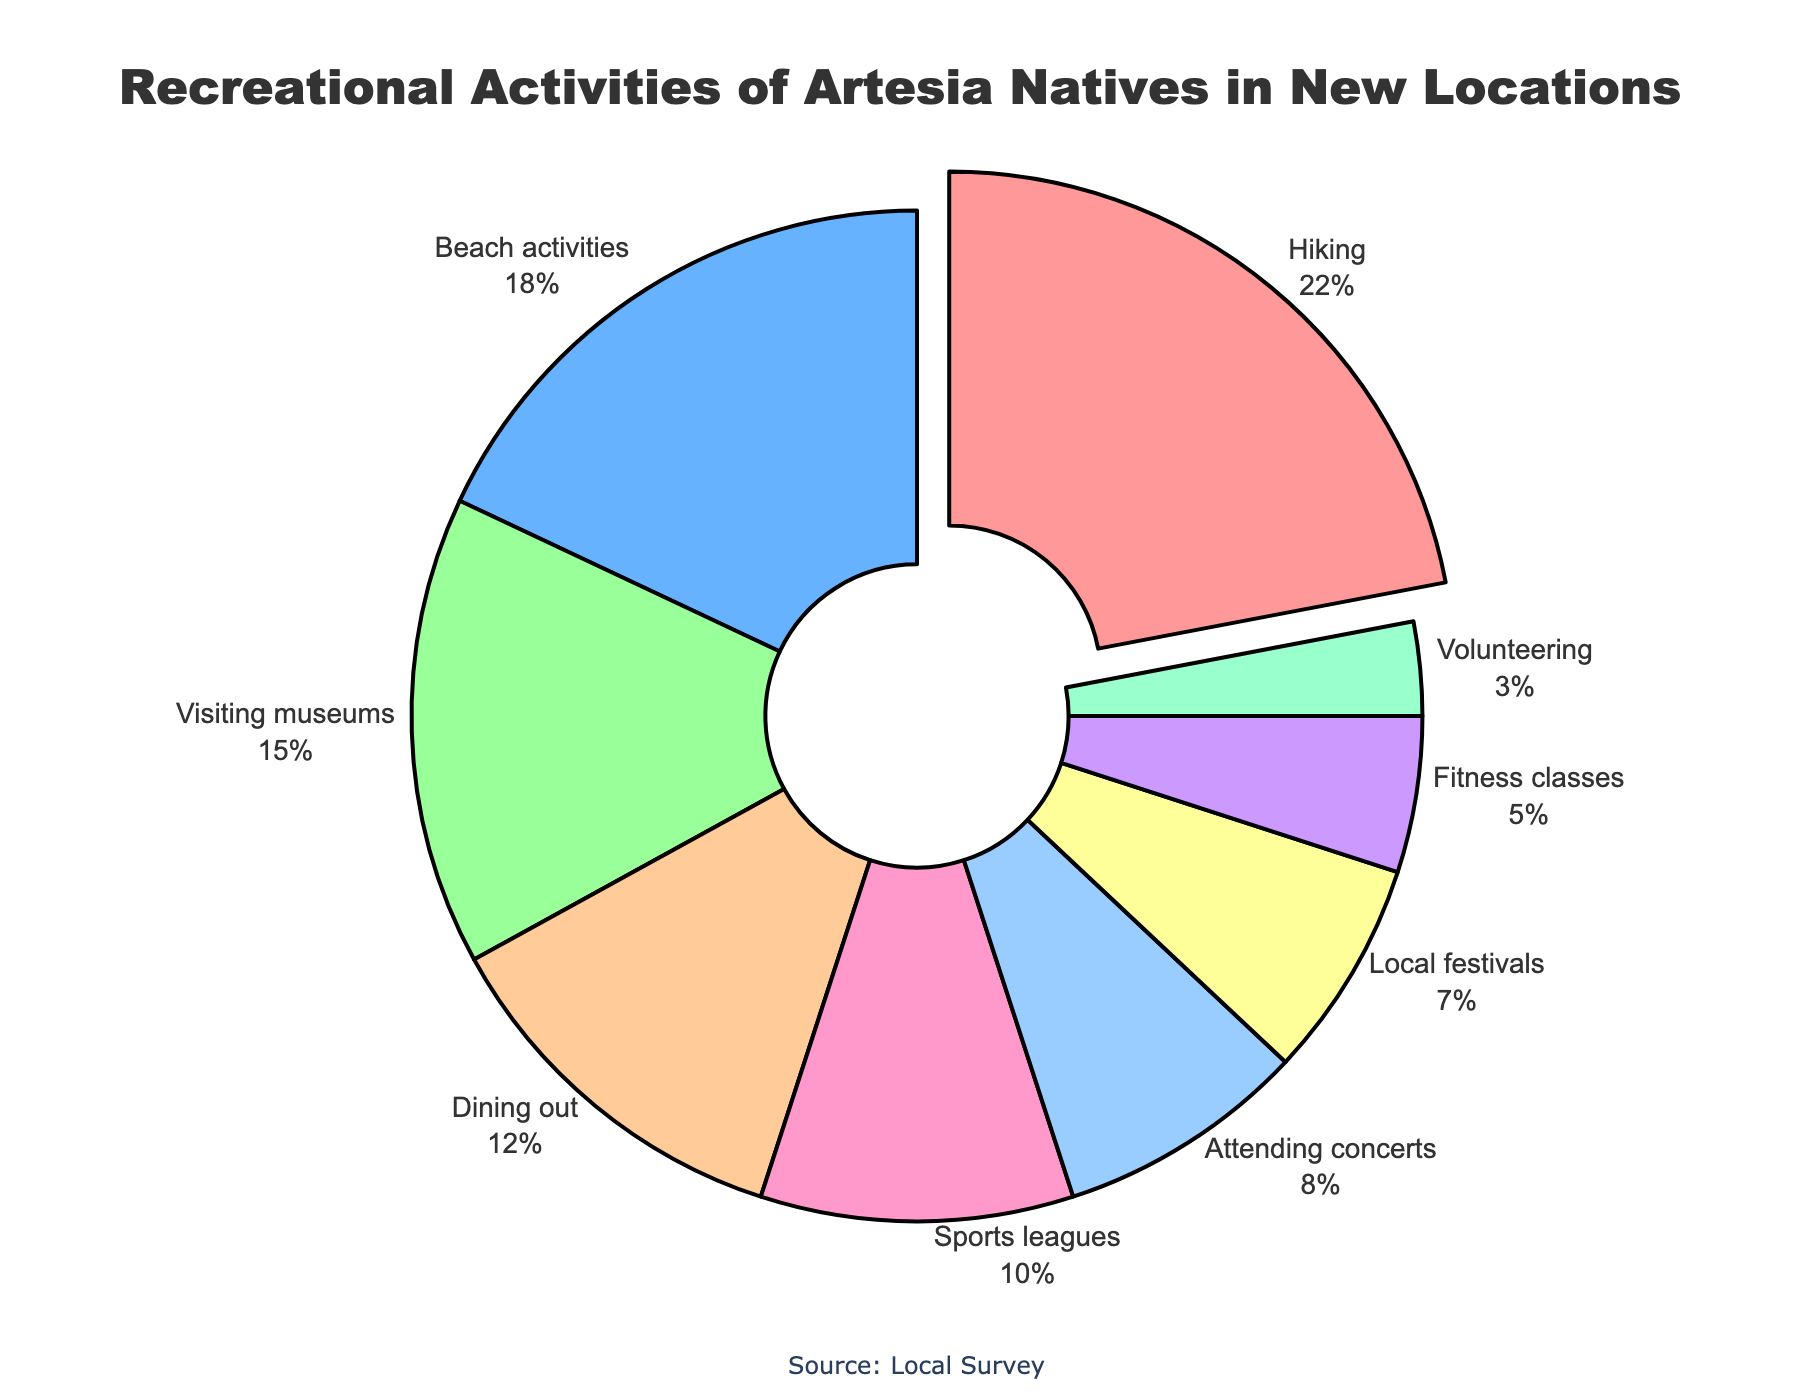What's the most popular recreational activity among Artesia natives in their new locations? Hiking has the highest percentage in the pie chart at 22%.
Answer: Hiking What percentage of activities do Beach activities and Dining out together represent? Sum the percentage for Beach activities (18%) and Dining out (12%): 18% + 12% = 30%.
Answer: 30% Is attending concerts more popular than volunteering? Attending concerts (8%) has a higher percentage than volunteering (3%).
Answer: Yes Which activity has the smallest percentage of participants? Volunteering has the smallest percentage at 3%.
Answer: Volunteering How much less popular are local festivals compared to visiting museums? Subtract the percentage of Local festivals (7%) from Visiting museums (15%): 15% - 7% = 8%.
Answer: 8% Compare the participation in fitness classes to sports leagues. Which one has a higher percentage, and by how much? Sports leagues have 10%, while Fitness classes have 5%. Calculate the difference: 10% - 5% = 5%.
Answer: Sports leagues, by 5% What proportion of the overall activities is made up by the top three activities combined? Add the percentages of the top three activities: Hiking (22%), Beach activities (18%), and Visiting museums (15%): 22% + 18% + 15% = 55%.
Answer: 55% What is the average percentage of the four least popular activities? Identify the least popular activities: Fitness classes (5%), Local festivals (7%), Attending concerts (8%), Volunteering (3%). Calculate the average: (5% + 7% + 8% + 3%) / 4 = 5.75%.
Answer: 5.75% What is the color of the slice representing Attending concerts? The slice for Attending concerts is represented by the blue color.
Answer: Blue 